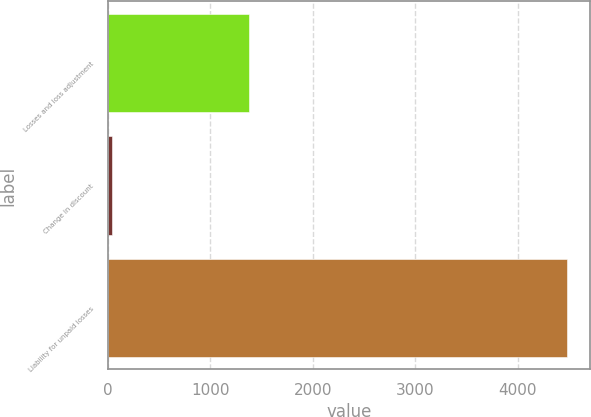Convert chart to OTSL. <chart><loc_0><loc_0><loc_500><loc_500><bar_chart><fcel>Losses and loss adjustment<fcel>Change in discount<fcel>Liability for unpaid losses<nl><fcel>1372.8<fcel>39<fcel>4485<nl></chart> 